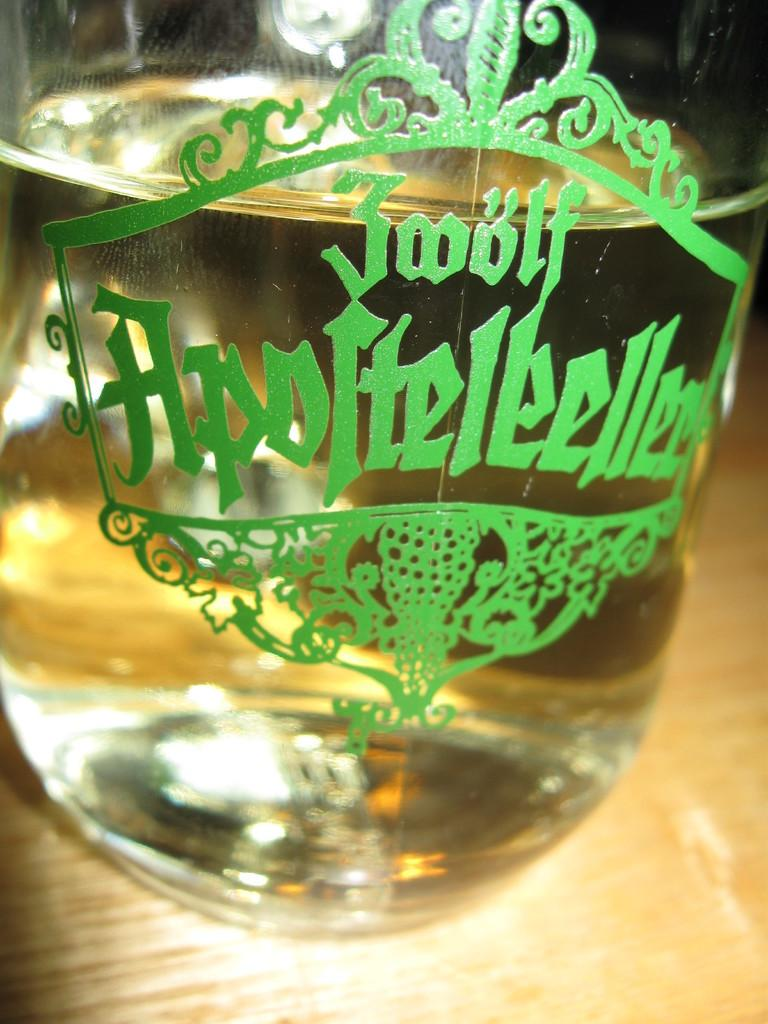What object is present in the image that can hold liquid? There is a glass in the image. What is inside the glass? The glass contains liquid. What type of sock is being used to kick the snake in the image? There is no sock or snake present in the image; it only features a glass containing liquid. 